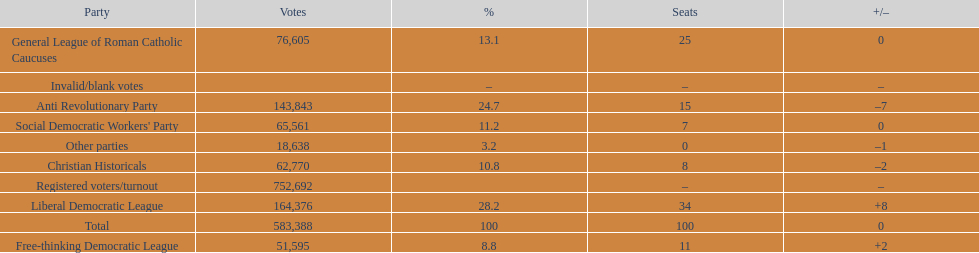How many votes were counted as invalid or blank votes? 0. 